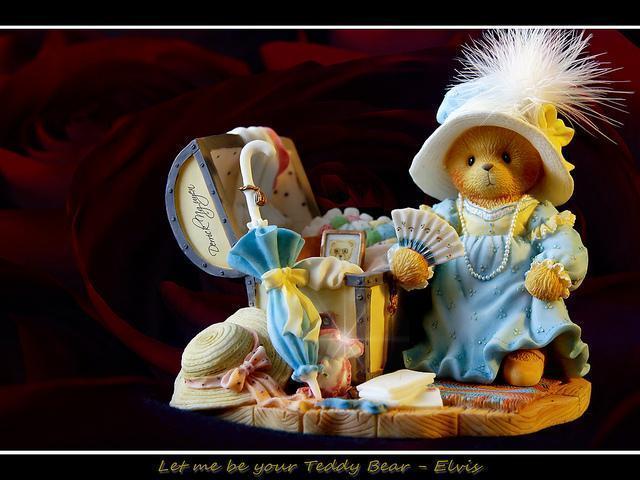Is "The teddy bear is right of the umbrella." an appropriate description for the image?
Answer yes or no. Yes. Does the image validate the caption "The umbrella is over the teddy bear."?
Answer yes or no. No. Is "The teddy bear is under the umbrella." an appropriate description for the image?
Answer yes or no. No. Does the caption "The teddy bear is beneath the umbrella." correctly depict the image?
Answer yes or no. No. Is the given caption "The teddy bear is below the umbrella." fitting for the image?
Answer yes or no. No. Does the image validate the caption "The umbrella is left of the teddy bear."?
Answer yes or no. Yes. 